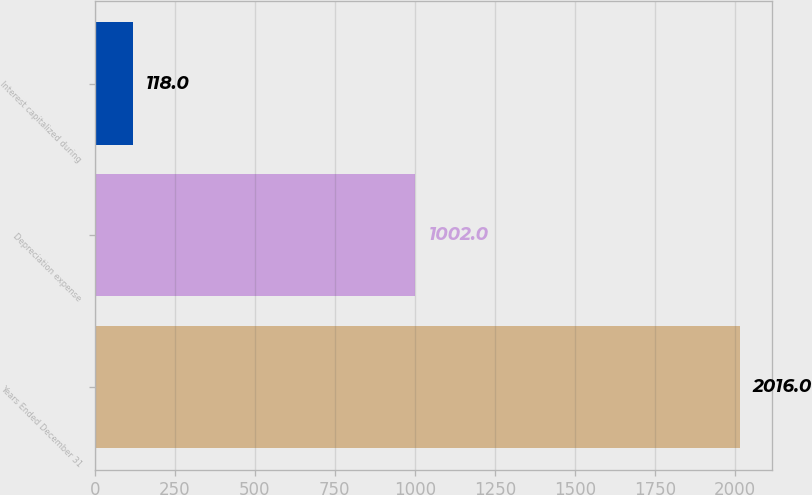Convert chart to OTSL. <chart><loc_0><loc_0><loc_500><loc_500><bar_chart><fcel>Years Ended December 31<fcel>Depreciation expense<fcel>Interest capitalized during<nl><fcel>2016<fcel>1002<fcel>118<nl></chart> 